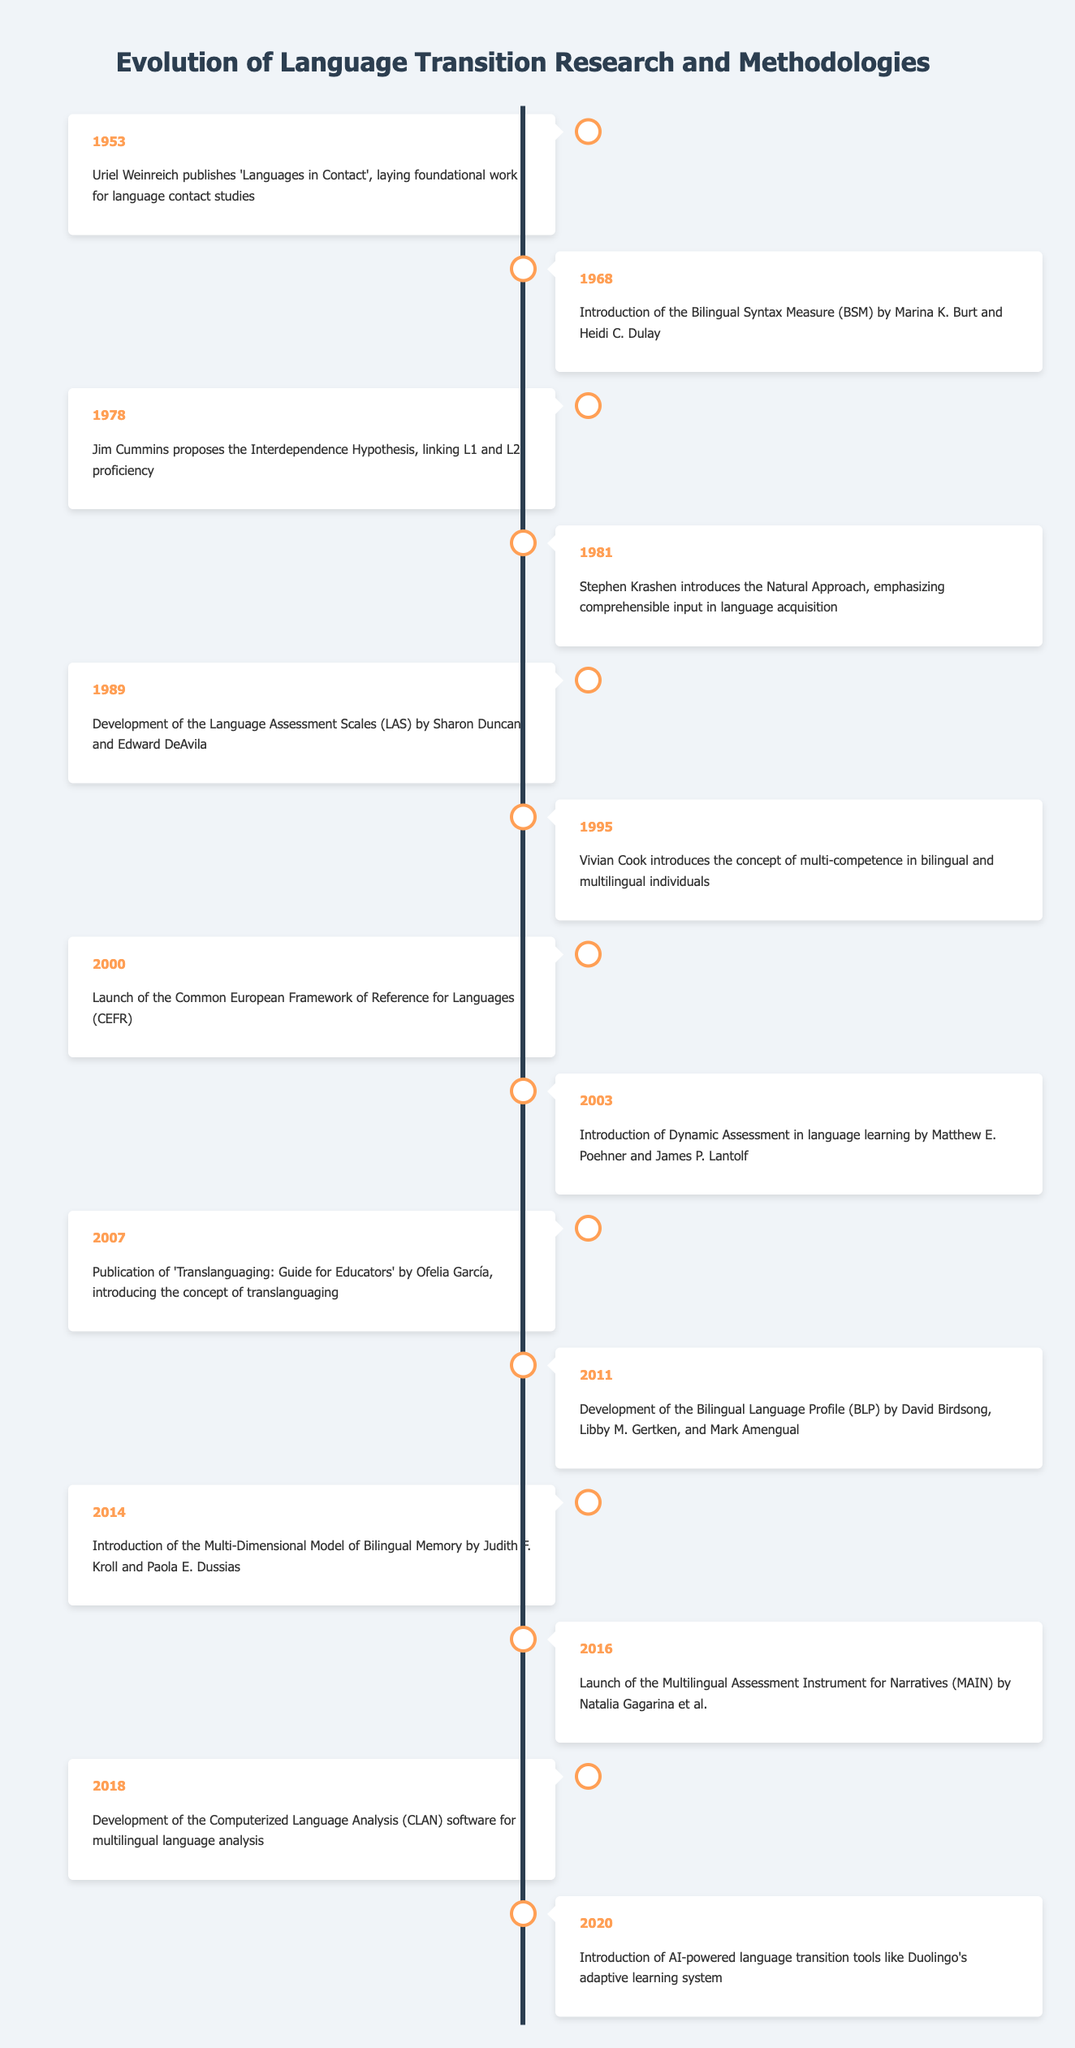What year did Uriel Weinreich publish 'Languages in Contact'? According to the table, Uriel Weinreich published 'Languages in Contact' in 1953.
Answer: 1953 What is the main contribution of the publication in 2007? The publication in 2007 by Ofelia García is significant as it introduces the concept of translanguaging for educators.
Answer: Introduction of translanguaging How many events are listed between 1978 and 2000? The events listed between 1978 and 2000 are three: in 1978, 1981, and 1989, making a total of three events.
Answer: 3 Did the concept of multi-competence get introduced before the Bilingual Language Profile? Yes, the concept of multi-competence was introduced in 1995 and the Bilingual Language Profile was developed in 2011, indicating multi-competence was introduced earlier.
Answer: Yes What is the average gap in years between the listed events from 1953 to 2020? To find the average gap, calculate the difference between each consecutive year, which gives [15, 10, 3, 8, 6, 5, 3, 4, 4, 3, 2, 2, 2] totaling 69 years across 13 gaps. Therefore, the average gap is 69/13 ≈ 5.31 years.
Answer: Approximately 5.31 years What event from 2011 focused on bilingual profiling? The event from 2011 that focused on bilingual profiling is the development of the Bilingual Language Profile (BLP) by David Birdsong and others.
Answer: Development of the BLP How many years passed between the introduction of the Common European Framework of Reference for Languages and the launch of AI-powered language transition tools? The Common European Framework of Reference for Languages was launched in 2000 and the AI-powered tools were introduced in 2020, which indicates a 20-year gap.
Answer: 20 years Was Dynamic Assessment introduced after the Common European Framework of Reference for Languages? Yes, Dynamic Assessment was introduced in 2003, which is after 2000 when the Common European Framework was launched.
Answer: Yes Which two events were linked to bilingual memory research, and in what years did they occur? The two events are the introduction of the Multi-Dimensional Model of Bilingual Memory in 2014 and the launch of the Multilingual Assessment Instrument for Narratives in 2016.
Answer: 2014 and 2016 